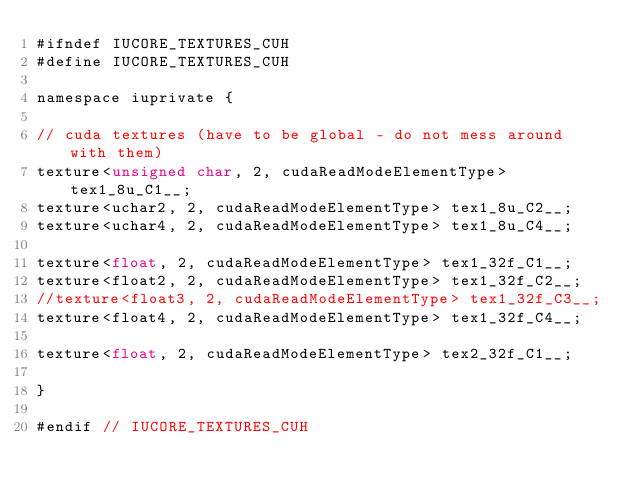<code> <loc_0><loc_0><loc_500><loc_500><_Cuda_>#ifndef IUCORE_TEXTURES_CUH
#define IUCORE_TEXTURES_CUH

namespace iuprivate {

// cuda textures (have to be global - do not mess around with them)
texture<unsigned char, 2, cudaReadModeElementType> tex1_8u_C1__;
texture<uchar2, 2, cudaReadModeElementType> tex1_8u_C2__;
texture<uchar4, 2, cudaReadModeElementType> tex1_8u_C4__;

texture<float, 2, cudaReadModeElementType> tex1_32f_C1__;
texture<float2, 2, cudaReadModeElementType> tex1_32f_C2__;
//texture<float3, 2, cudaReadModeElementType> tex1_32f_C3__;
texture<float4, 2, cudaReadModeElementType> tex1_32f_C4__;

texture<float, 2, cudaReadModeElementType> tex2_32f_C1__;

}

#endif // IUCORE_TEXTURES_CUH
</code> 